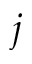Convert formula to latex. <formula><loc_0><loc_0><loc_500><loc_500>j</formula> 